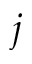Convert formula to latex. <formula><loc_0><loc_0><loc_500><loc_500>j</formula> 